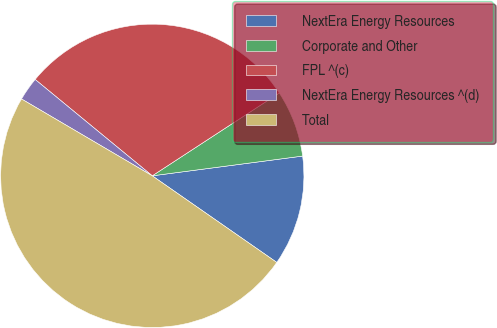Convert chart. <chart><loc_0><loc_0><loc_500><loc_500><pie_chart><fcel>NextEra Energy Resources<fcel>Corporate and Other<fcel>FPL ^(c)<fcel>NextEra Energy Resources ^(d)<fcel>Total<nl><fcel>11.75%<fcel>7.12%<fcel>29.84%<fcel>2.5%<fcel>48.78%<nl></chart> 